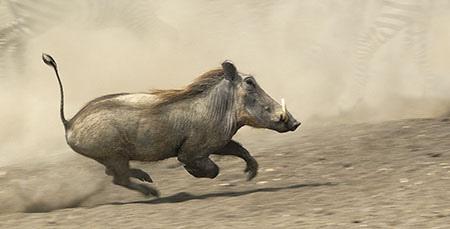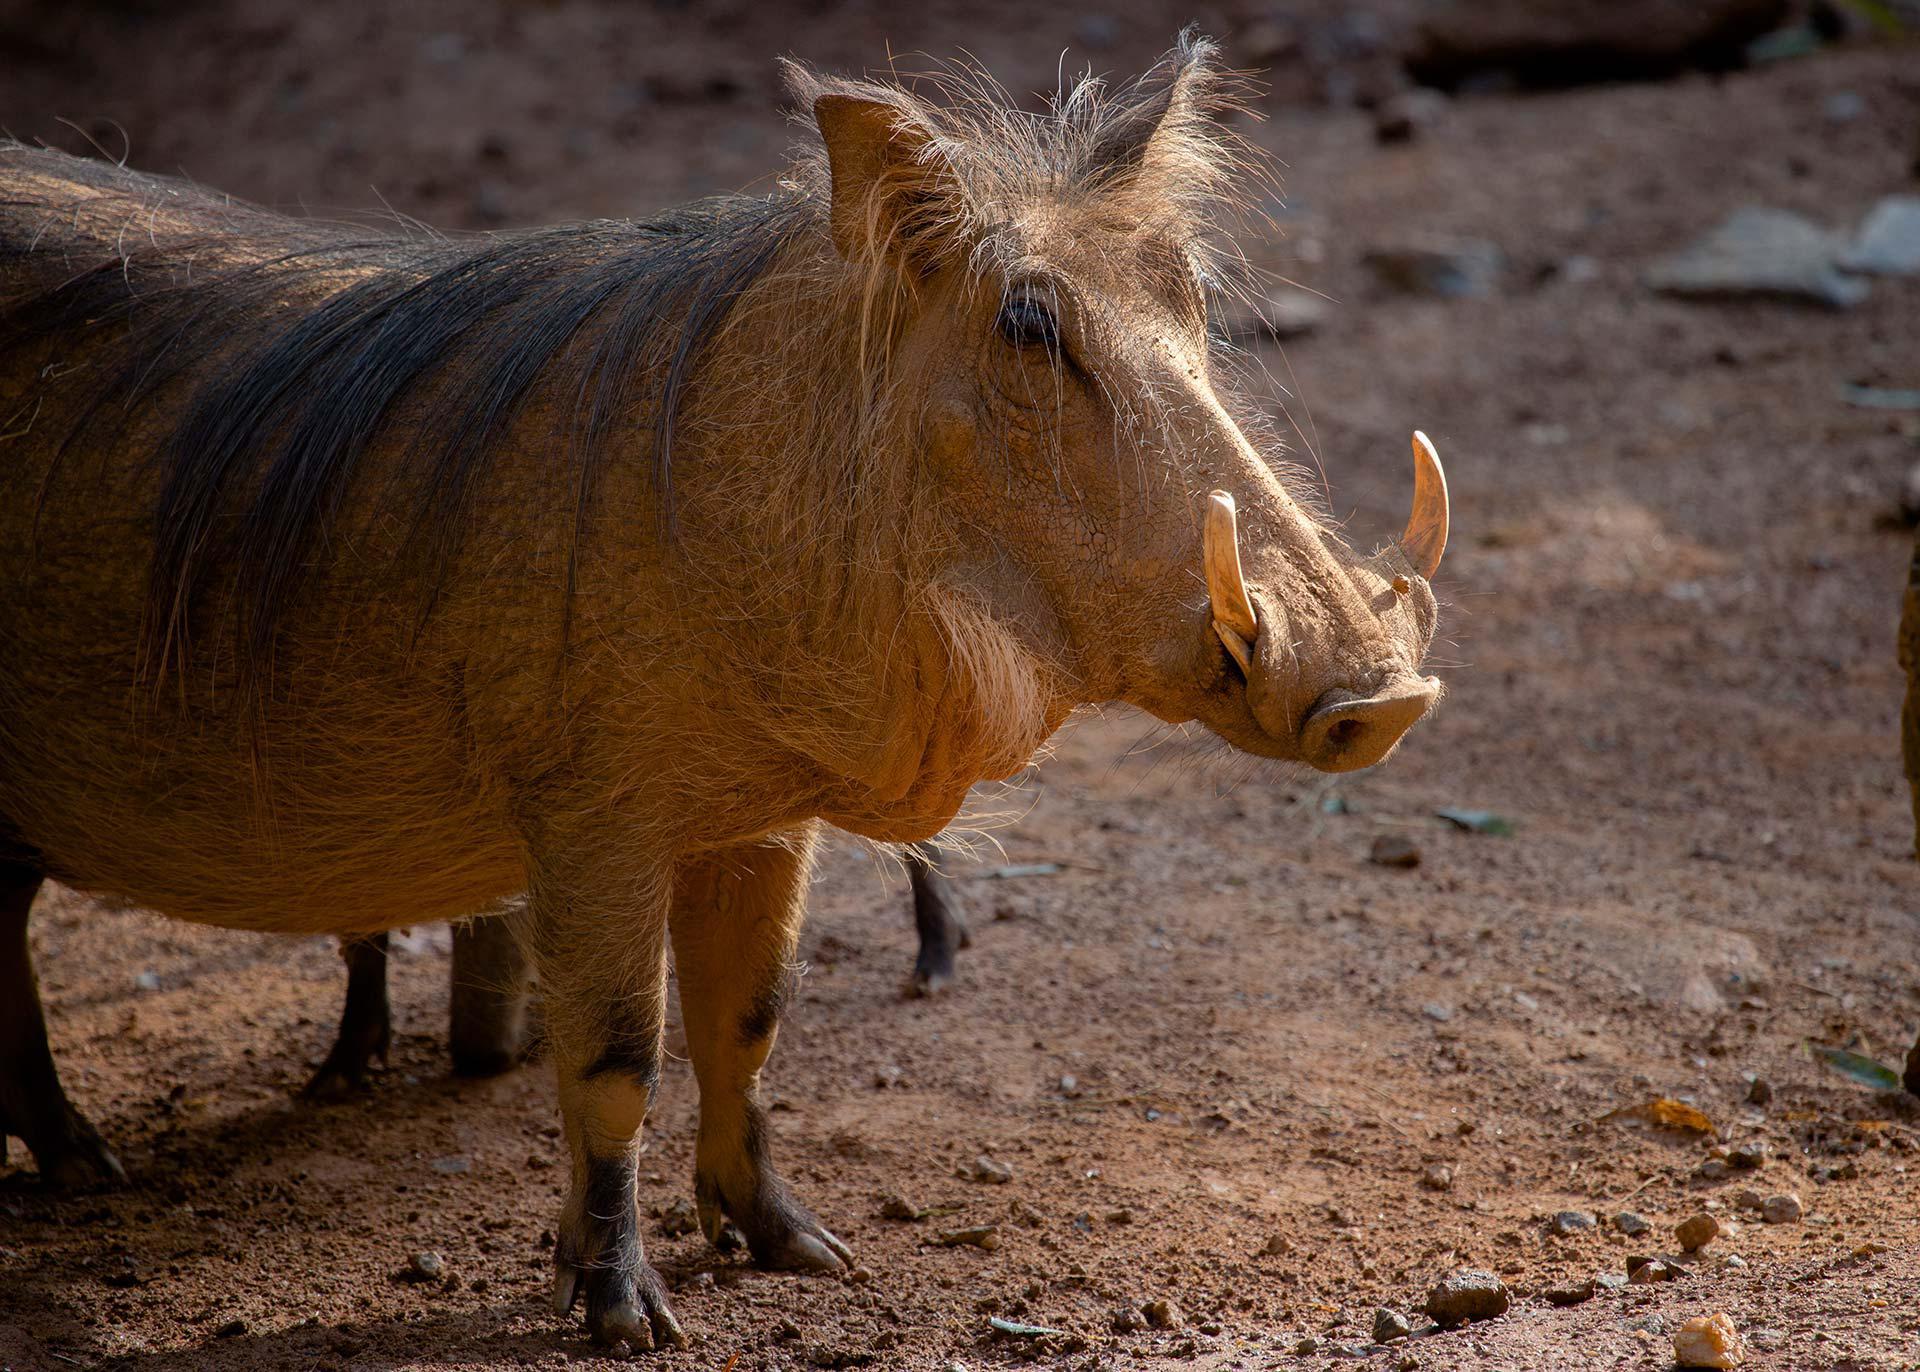The first image is the image on the left, the second image is the image on the right. Examine the images to the left and right. Is the description "There are two hogs in total." accurate? Answer yes or no. Yes. The first image is the image on the left, the second image is the image on the right. Given the left and right images, does the statement "Each image includes a warthog with its head facing the camera." hold true? Answer yes or no. No. 